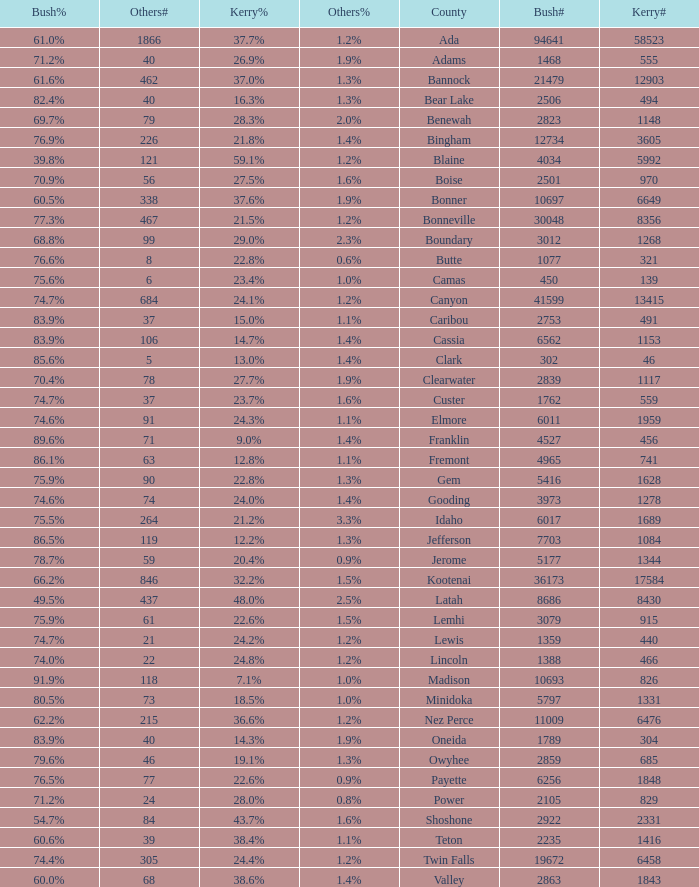How many people voted for Kerry in the county where 8 voted for others? 321.0. 